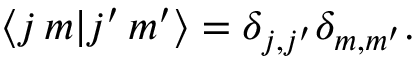<formula> <loc_0><loc_0><loc_500><loc_500>\langle j \, m | j ^ { \prime } \, m ^ { \prime } \rangle = \delta _ { j , j ^ { \prime } } \delta _ { m , m ^ { \prime } } .</formula> 